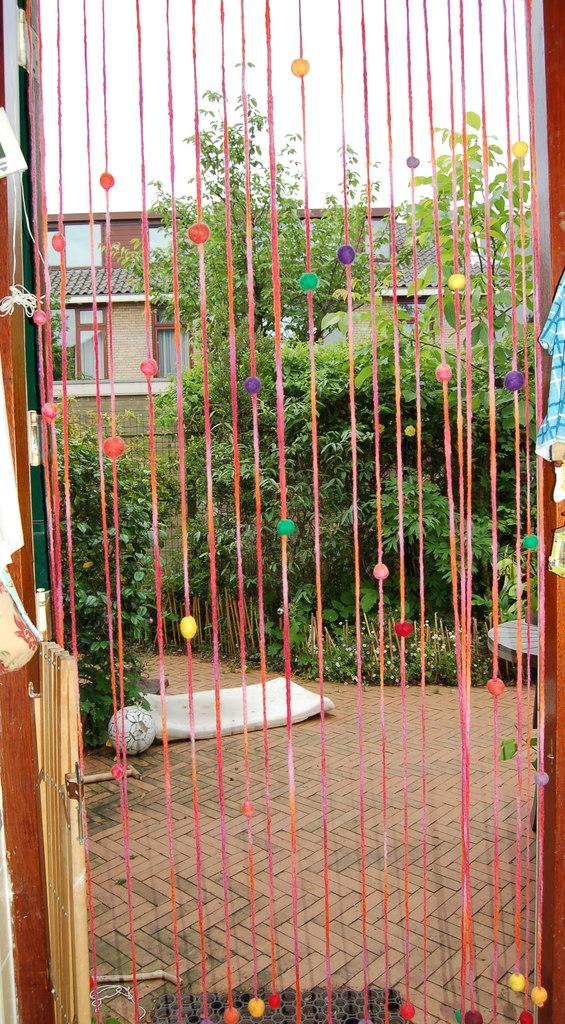What type of natural elements are present in the image? There are plants and trees in the image. What type of man-made structure can be seen in the image? There is a house-like structure in the image. What is visible at the top of the image? The sky is visible at the top of the image. Is there a volcano erupting in the background of the image? No, there is no volcano present in the image. Can you see any ghosts in the image? No, there are no ghosts present in the image. 